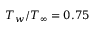<formula> <loc_0><loc_0><loc_500><loc_500>T _ { w } / T _ { \infty } = 0 . 7 5</formula> 